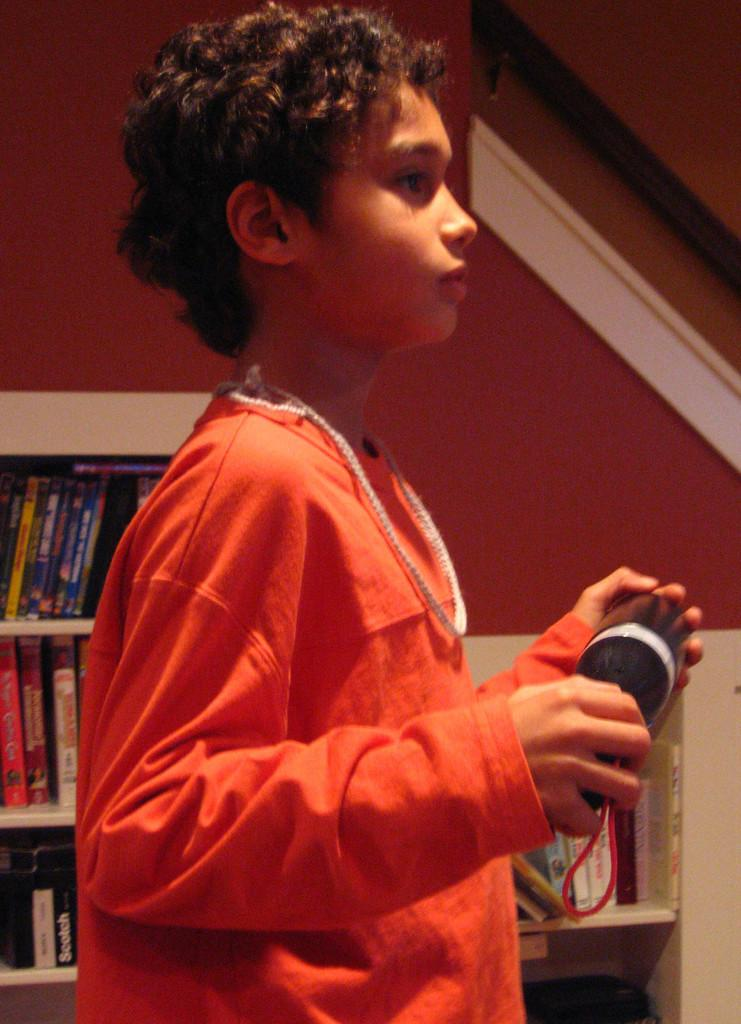What is the person in the image doing? The person is standing in the image. What is the person holding in the image? The person is holding a black object. What can be seen in the background of the image? There is a wall with racks in the background of the image. What type of items are on the racks? There are different types of books on the racks. What type of prose is the person reading in the image? There is no indication in the image that the person is reading any prose, as they are holding a black object and not interacting with any books. 